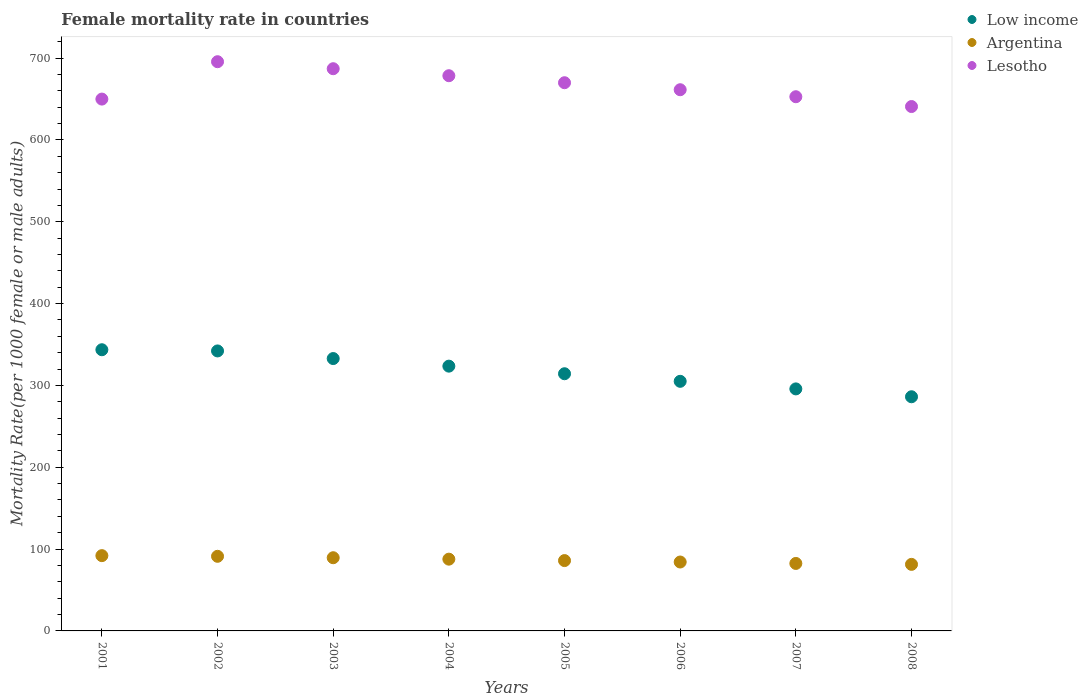How many different coloured dotlines are there?
Provide a short and direct response. 3. Is the number of dotlines equal to the number of legend labels?
Ensure brevity in your answer.  Yes. What is the female mortality rate in Low income in 2005?
Give a very brief answer. 314.28. Across all years, what is the maximum female mortality rate in Argentina?
Make the answer very short. 91.99. Across all years, what is the minimum female mortality rate in Argentina?
Ensure brevity in your answer.  81.32. In which year was the female mortality rate in Low income maximum?
Your answer should be compact. 2001. What is the total female mortality rate in Argentina in the graph?
Give a very brief answer. 694.26. What is the difference between the female mortality rate in Low income in 2006 and that in 2007?
Your response must be concise. 9.27. What is the difference between the female mortality rate in Argentina in 2002 and the female mortality rate in Low income in 2007?
Offer a very short reply. -204.57. What is the average female mortality rate in Low income per year?
Your answer should be compact. 317.92. In the year 2006, what is the difference between the female mortality rate in Low income and female mortality rate in Argentina?
Keep it short and to the point. 220.81. What is the ratio of the female mortality rate in Argentina in 2003 to that in 2006?
Provide a succinct answer. 1.06. Is the female mortality rate in Argentina in 2004 less than that in 2008?
Provide a short and direct response. No. What is the difference between the highest and the second highest female mortality rate in Argentina?
Make the answer very short. 0.81. What is the difference between the highest and the lowest female mortality rate in Lesotho?
Give a very brief answer. 54.78. In how many years, is the female mortality rate in Lesotho greater than the average female mortality rate in Lesotho taken over all years?
Provide a short and direct response. 4. Is the female mortality rate in Argentina strictly greater than the female mortality rate in Low income over the years?
Make the answer very short. No. How many years are there in the graph?
Your answer should be very brief. 8. What is the difference between two consecutive major ticks on the Y-axis?
Keep it short and to the point. 100. Are the values on the major ticks of Y-axis written in scientific E-notation?
Ensure brevity in your answer.  No. Does the graph contain grids?
Ensure brevity in your answer.  No. Where does the legend appear in the graph?
Provide a succinct answer. Top right. How many legend labels are there?
Offer a very short reply. 3. How are the legend labels stacked?
Ensure brevity in your answer.  Vertical. What is the title of the graph?
Provide a succinct answer. Female mortality rate in countries. Does "North America" appear as one of the legend labels in the graph?
Provide a succinct answer. No. What is the label or title of the X-axis?
Offer a very short reply. Years. What is the label or title of the Y-axis?
Make the answer very short. Mortality Rate(per 1000 female or male adults). What is the Mortality Rate(per 1000 female or male adults) in Low income in 2001?
Ensure brevity in your answer.  343.61. What is the Mortality Rate(per 1000 female or male adults) in Argentina in 2001?
Give a very brief answer. 91.99. What is the Mortality Rate(per 1000 female or male adults) of Lesotho in 2001?
Offer a very short reply. 649.91. What is the Mortality Rate(per 1000 female or male adults) of Low income in 2002?
Ensure brevity in your answer.  342.15. What is the Mortality Rate(per 1000 female or male adults) of Argentina in 2002?
Provide a succinct answer. 91.19. What is the Mortality Rate(per 1000 female or male adults) of Lesotho in 2002?
Offer a very short reply. 695.58. What is the Mortality Rate(per 1000 female or male adults) in Low income in 2003?
Offer a terse response. 332.83. What is the Mortality Rate(per 1000 female or male adults) in Argentina in 2003?
Provide a succinct answer. 89.44. What is the Mortality Rate(per 1000 female or male adults) of Lesotho in 2003?
Ensure brevity in your answer.  687.02. What is the Mortality Rate(per 1000 female or male adults) in Low income in 2004?
Your answer should be compact. 323.55. What is the Mortality Rate(per 1000 female or male adults) in Argentina in 2004?
Ensure brevity in your answer.  87.7. What is the Mortality Rate(per 1000 female or male adults) of Lesotho in 2004?
Your answer should be very brief. 678.46. What is the Mortality Rate(per 1000 female or male adults) of Low income in 2005?
Your answer should be very brief. 314.28. What is the Mortality Rate(per 1000 female or male adults) in Argentina in 2005?
Give a very brief answer. 85.95. What is the Mortality Rate(per 1000 female or male adults) in Lesotho in 2005?
Ensure brevity in your answer.  669.9. What is the Mortality Rate(per 1000 female or male adults) in Low income in 2006?
Your response must be concise. 305.02. What is the Mortality Rate(per 1000 female or male adults) of Argentina in 2006?
Ensure brevity in your answer.  84.21. What is the Mortality Rate(per 1000 female or male adults) in Lesotho in 2006?
Keep it short and to the point. 661.34. What is the Mortality Rate(per 1000 female or male adults) of Low income in 2007?
Provide a short and direct response. 295.75. What is the Mortality Rate(per 1000 female or male adults) in Argentina in 2007?
Your answer should be compact. 82.46. What is the Mortality Rate(per 1000 female or male adults) in Lesotho in 2007?
Offer a terse response. 652.78. What is the Mortality Rate(per 1000 female or male adults) of Low income in 2008?
Ensure brevity in your answer.  286.15. What is the Mortality Rate(per 1000 female or male adults) in Argentina in 2008?
Your answer should be compact. 81.32. What is the Mortality Rate(per 1000 female or male adults) in Lesotho in 2008?
Keep it short and to the point. 640.81. Across all years, what is the maximum Mortality Rate(per 1000 female or male adults) of Low income?
Ensure brevity in your answer.  343.61. Across all years, what is the maximum Mortality Rate(per 1000 female or male adults) in Argentina?
Provide a short and direct response. 91.99. Across all years, what is the maximum Mortality Rate(per 1000 female or male adults) of Lesotho?
Provide a succinct answer. 695.58. Across all years, what is the minimum Mortality Rate(per 1000 female or male adults) in Low income?
Make the answer very short. 286.15. Across all years, what is the minimum Mortality Rate(per 1000 female or male adults) in Argentina?
Ensure brevity in your answer.  81.32. Across all years, what is the minimum Mortality Rate(per 1000 female or male adults) in Lesotho?
Give a very brief answer. 640.81. What is the total Mortality Rate(per 1000 female or male adults) in Low income in the graph?
Provide a short and direct response. 2543.33. What is the total Mortality Rate(per 1000 female or male adults) of Argentina in the graph?
Your response must be concise. 694.26. What is the total Mortality Rate(per 1000 female or male adults) in Lesotho in the graph?
Keep it short and to the point. 5335.82. What is the difference between the Mortality Rate(per 1000 female or male adults) of Low income in 2001 and that in 2002?
Ensure brevity in your answer.  1.46. What is the difference between the Mortality Rate(per 1000 female or male adults) in Argentina in 2001 and that in 2002?
Your answer should be compact. 0.81. What is the difference between the Mortality Rate(per 1000 female or male adults) in Lesotho in 2001 and that in 2002?
Ensure brevity in your answer.  -45.67. What is the difference between the Mortality Rate(per 1000 female or male adults) of Low income in 2001 and that in 2003?
Make the answer very short. 10.77. What is the difference between the Mortality Rate(per 1000 female or male adults) in Argentina in 2001 and that in 2003?
Your response must be concise. 2.55. What is the difference between the Mortality Rate(per 1000 female or male adults) of Lesotho in 2001 and that in 2003?
Provide a succinct answer. -37.11. What is the difference between the Mortality Rate(per 1000 female or male adults) in Low income in 2001 and that in 2004?
Ensure brevity in your answer.  20.06. What is the difference between the Mortality Rate(per 1000 female or male adults) of Argentina in 2001 and that in 2004?
Make the answer very short. 4.3. What is the difference between the Mortality Rate(per 1000 female or male adults) of Lesotho in 2001 and that in 2004?
Your response must be concise. -28.55. What is the difference between the Mortality Rate(per 1000 female or male adults) of Low income in 2001 and that in 2005?
Offer a very short reply. 29.33. What is the difference between the Mortality Rate(per 1000 female or male adults) in Argentina in 2001 and that in 2005?
Give a very brief answer. 6.04. What is the difference between the Mortality Rate(per 1000 female or male adults) in Lesotho in 2001 and that in 2005?
Offer a very short reply. -19.99. What is the difference between the Mortality Rate(per 1000 female or male adults) of Low income in 2001 and that in 2006?
Keep it short and to the point. 38.59. What is the difference between the Mortality Rate(per 1000 female or male adults) of Argentina in 2001 and that in 2006?
Your answer should be compact. 7.79. What is the difference between the Mortality Rate(per 1000 female or male adults) in Lesotho in 2001 and that in 2006?
Your answer should be very brief. -11.43. What is the difference between the Mortality Rate(per 1000 female or male adults) in Low income in 2001 and that in 2007?
Provide a succinct answer. 47.85. What is the difference between the Mortality Rate(per 1000 female or male adults) in Argentina in 2001 and that in 2007?
Make the answer very short. 9.53. What is the difference between the Mortality Rate(per 1000 female or male adults) of Lesotho in 2001 and that in 2007?
Make the answer very short. -2.88. What is the difference between the Mortality Rate(per 1000 female or male adults) of Low income in 2001 and that in 2008?
Provide a short and direct response. 57.46. What is the difference between the Mortality Rate(per 1000 female or male adults) in Argentina in 2001 and that in 2008?
Give a very brief answer. 10.67. What is the difference between the Mortality Rate(per 1000 female or male adults) of Lesotho in 2001 and that in 2008?
Offer a terse response. 9.1. What is the difference between the Mortality Rate(per 1000 female or male adults) in Low income in 2002 and that in 2003?
Ensure brevity in your answer.  9.31. What is the difference between the Mortality Rate(per 1000 female or male adults) in Argentina in 2002 and that in 2003?
Give a very brief answer. 1.75. What is the difference between the Mortality Rate(per 1000 female or male adults) of Lesotho in 2002 and that in 2003?
Offer a very short reply. 8.56. What is the difference between the Mortality Rate(per 1000 female or male adults) in Low income in 2002 and that in 2004?
Provide a succinct answer. 18.6. What is the difference between the Mortality Rate(per 1000 female or male adults) in Argentina in 2002 and that in 2004?
Give a very brief answer. 3.49. What is the difference between the Mortality Rate(per 1000 female or male adults) of Lesotho in 2002 and that in 2004?
Offer a very short reply. 17.12. What is the difference between the Mortality Rate(per 1000 female or male adults) in Low income in 2002 and that in 2005?
Offer a terse response. 27.87. What is the difference between the Mortality Rate(per 1000 female or male adults) in Argentina in 2002 and that in 2005?
Your answer should be compact. 5.24. What is the difference between the Mortality Rate(per 1000 female or male adults) of Lesotho in 2002 and that in 2005?
Provide a succinct answer. 25.68. What is the difference between the Mortality Rate(per 1000 female or male adults) of Low income in 2002 and that in 2006?
Your answer should be very brief. 37.13. What is the difference between the Mortality Rate(per 1000 female or male adults) of Argentina in 2002 and that in 2006?
Provide a succinct answer. 6.98. What is the difference between the Mortality Rate(per 1000 female or male adults) in Lesotho in 2002 and that in 2006?
Keep it short and to the point. 34.24. What is the difference between the Mortality Rate(per 1000 female or male adults) of Low income in 2002 and that in 2007?
Offer a terse response. 46.39. What is the difference between the Mortality Rate(per 1000 female or male adults) of Argentina in 2002 and that in 2007?
Provide a succinct answer. 8.73. What is the difference between the Mortality Rate(per 1000 female or male adults) in Lesotho in 2002 and that in 2007?
Provide a short and direct response. 42.8. What is the difference between the Mortality Rate(per 1000 female or male adults) in Low income in 2002 and that in 2008?
Give a very brief answer. 56. What is the difference between the Mortality Rate(per 1000 female or male adults) in Argentina in 2002 and that in 2008?
Your answer should be very brief. 9.87. What is the difference between the Mortality Rate(per 1000 female or male adults) of Lesotho in 2002 and that in 2008?
Give a very brief answer. 54.78. What is the difference between the Mortality Rate(per 1000 female or male adults) of Low income in 2003 and that in 2004?
Offer a very short reply. 9.29. What is the difference between the Mortality Rate(per 1000 female or male adults) in Argentina in 2003 and that in 2004?
Provide a succinct answer. 1.75. What is the difference between the Mortality Rate(per 1000 female or male adults) in Lesotho in 2003 and that in 2004?
Provide a succinct answer. 8.56. What is the difference between the Mortality Rate(per 1000 female or male adults) in Low income in 2003 and that in 2005?
Ensure brevity in your answer.  18.56. What is the difference between the Mortality Rate(per 1000 female or male adults) of Argentina in 2003 and that in 2005?
Make the answer very short. 3.49. What is the difference between the Mortality Rate(per 1000 female or male adults) of Lesotho in 2003 and that in 2005?
Ensure brevity in your answer.  17.12. What is the difference between the Mortality Rate(per 1000 female or male adults) in Low income in 2003 and that in 2006?
Your answer should be very brief. 27.82. What is the difference between the Mortality Rate(per 1000 female or male adults) in Argentina in 2003 and that in 2006?
Ensure brevity in your answer.  5.24. What is the difference between the Mortality Rate(per 1000 female or male adults) of Lesotho in 2003 and that in 2006?
Your answer should be very brief. 25.68. What is the difference between the Mortality Rate(per 1000 female or male adults) of Low income in 2003 and that in 2007?
Your response must be concise. 37.08. What is the difference between the Mortality Rate(per 1000 female or male adults) in Argentina in 2003 and that in 2007?
Give a very brief answer. 6.98. What is the difference between the Mortality Rate(per 1000 female or male adults) of Lesotho in 2003 and that in 2007?
Keep it short and to the point. 34.24. What is the difference between the Mortality Rate(per 1000 female or male adults) of Low income in 2003 and that in 2008?
Keep it short and to the point. 46.69. What is the difference between the Mortality Rate(per 1000 female or male adults) in Argentina in 2003 and that in 2008?
Your answer should be very brief. 8.12. What is the difference between the Mortality Rate(per 1000 female or male adults) of Lesotho in 2003 and that in 2008?
Give a very brief answer. 46.22. What is the difference between the Mortality Rate(per 1000 female or male adults) in Low income in 2004 and that in 2005?
Ensure brevity in your answer.  9.27. What is the difference between the Mortality Rate(per 1000 female or male adults) of Argentina in 2004 and that in 2005?
Ensure brevity in your answer.  1.75. What is the difference between the Mortality Rate(per 1000 female or male adults) in Lesotho in 2004 and that in 2005?
Keep it short and to the point. 8.56. What is the difference between the Mortality Rate(per 1000 female or male adults) in Low income in 2004 and that in 2006?
Your answer should be very brief. 18.53. What is the difference between the Mortality Rate(per 1000 female or male adults) of Argentina in 2004 and that in 2006?
Give a very brief answer. 3.49. What is the difference between the Mortality Rate(per 1000 female or male adults) in Lesotho in 2004 and that in 2006?
Keep it short and to the point. 17.12. What is the difference between the Mortality Rate(per 1000 female or male adults) of Low income in 2004 and that in 2007?
Your answer should be very brief. 27.8. What is the difference between the Mortality Rate(per 1000 female or male adults) in Argentina in 2004 and that in 2007?
Ensure brevity in your answer.  5.24. What is the difference between the Mortality Rate(per 1000 female or male adults) in Lesotho in 2004 and that in 2007?
Provide a short and direct response. 25.68. What is the difference between the Mortality Rate(per 1000 female or male adults) of Low income in 2004 and that in 2008?
Provide a succinct answer. 37.4. What is the difference between the Mortality Rate(per 1000 female or male adults) in Argentina in 2004 and that in 2008?
Your answer should be compact. 6.38. What is the difference between the Mortality Rate(per 1000 female or male adults) of Lesotho in 2004 and that in 2008?
Keep it short and to the point. 37.66. What is the difference between the Mortality Rate(per 1000 female or male adults) of Low income in 2005 and that in 2006?
Ensure brevity in your answer.  9.26. What is the difference between the Mortality Rate(per 1000 female or male adults) in Argentina in 2005 and that in 2006?
Keep it short and to the point. 1.75. What is the difference between the Mortality Rate(per 1000 female or male adults) of Lesotho in 2005 and that in 2006?
Your answer should be compact. 8.56. What is the difference between the Mortality Rate(per 1000 female or male adults) in Low income in 2005 and that in 2007?
Offer a very short reply. 18.53. What is the difference between the Mortality Rate(per 1000 female or male adults) of Argentina in 2005 and that in 2007?
Offer a terse response. 3.49. What is the difference between the Mortality Rate(per 1000 female or male adults) in Lesotho in 2005 and that in 2007?
Offer a very short reply. 17.12. What is the difference between the Mortality Rate(per 1000 female or male adults) in Low income in 2005 and that in 2008?
Offer a very short reply. 28.13. What is the difference between the Mortality Rate(per 1000 female or male adults) in Argentina in 2005 and that in 2008?
Keep it short and to the point. 4.63. What is the difference between the Mortality Rate(per 1000 female or male adults) in Lesotho in 2005 and that in 2008?
Offer a terse response. 29.1. What is the difference between the Mortality Rate(per 1000 female or male adults) in Low income in 2006 and that in 2007?
Offer a terse response. 9.27. What is the difference between the Mortality Rate(per 1000 female or male adults) in Argentina in 2006 and that in 2007?
Your response must be concise. 1.75. What is the difference between the Mortality Rate(per 1000 female or male adults) of Lesotho in 2006 and that in 2007?
Make the answer very short. 8.56. What is the difference between the Mortality Rate(per 1000 female or male adults) in Low income in 2006 and that in 2008?
Make the answer very short. 18.87. What is the difference between the Mortality Rate(per 1000 female or male adults) in Argentina in 2006 and that in 2008?
Offer a very short reply. 2.88. What is the difference between the Mortality Rate(per 1000 female or male adults) in Lesotho in 2006 and that in 2008?
Offer a terse response. 20.54. What is the difference between the Mortality Rate(per 1000 female or male adults) in Low income in 2007 and that in 2008?
Your response must be concise. 9.61. What is the difference between the Mortality Rate(per 1000 female or male adults) of Argentina in 2007 and that in 2008?
Offer a terse response. 1.14. What is the difference between the Mortality Rate(per 1000 female or male adults) of Lesotho in 2007 and that in 2008?
Your answer should be very brief. 11.98. What is the difference between the Mortality Rate(per 1000 female or male adults) of Low income in 2001 and the Mortality Rate(per 1000 female or male adults) of Argentina in 2002?
Offer a very short reply. 252.42. What is the difference between the Mortality Rate(per 1000 female or male adults) of Low income in 2001 and the Mortality Rate(per 1000 female or male adults) of Lesotho in 2002?
Offer a terse response. -351.98. What is the difference between the Mortality Rate(per 1000 female or male adults) of Argentina in 2001 and the Mortality Rate(per 1000 female or male adults) of Lesotho in 2002?
Your answer should be very brief. -603.59. What is the difference between the Mortality Rate(per 1000 female or male adults) in Low income in 2001 and the Mortality Rate(per 1000 female or male adults) in Argentina in 2003?
Ensure brevity in your answer.  254.16. What is the difference between the Mortality Rate(per 1000 female or male adults) of Low income in 2001 and the Mortality Rate(per 1000 female or male adults) of Lesotho in 2003?
Give a very brief answer. -343.42. What is the difference between the Mortality Rate(per 1000 female or male adults) in Argentina in 2001 and the Mortality Rate(per 1000 female or male adults) in Lesotho in 2003?
Your answer should be very brief. -595.03. What is the difference between the Mortality Rate(per 1000 female or male adults) of Low income in 2001 and the Mortality Rate(per 1000 female or male adults) of Argentina in 2004?
Your answer should be very brief. 255.91. What is the difference between the Mortality Rate(per 1000 female or male adults) in Low income in 2001 and the Mortality Rate(per 1000 female or male adults) in Lesotho in 2004?
Your response must be concise. -334.86. What is the difference between the Mortality Rate(per 1000 female or male adults) in Argentina in 2001 and the Mortality Rate(per 1000 female or male adults) in Lesotho in 2004?
Your answer should be compact. -586.47. What is the difference between the Mortality Rate(per 1000 female or male adults) of Low income in 2001 and the Mortality Rate(per 1000 female or male adults) of Argentina in 2005?
Ensure brevity in your answer.  257.65. What is the difference between the Mortality Rate(per 1000 female or male adults) of Low income in 2001 and the Mortality Rate(per 1000 female or male adults) of Lesotho in 2005?
Offer a very short reply. -326.3. What is the difference between the Mortality Rate(per 1000 female or male adults) in Argentina in 2001 and the Mortality Rate(per 1000 female or male adults) in Lesotho in 2005?
Offer a very short reply. -577.91. What is the difference between the Mortality Rate(per 1000 female or male adults) in Low income in 2001 and the Mortality Rate(per 1000 female or male adults) in Argentina in 2006?
Make the answer very short. 259.4. What is the difference between the Mortality Rate(per 1000 female or male adults) of Low income in 2001 and the Mortality Rate(per 1000 female or male adults) of Lesotho in 2006?
Offer a terse response. -317.74. What is the difference between the Mortality Rate(per 1000 female or male adults) in Argentina in 2001 and the Mortality Rate(per 1000 female or male adults) in Lesotho in 2006?
Offer a terse response. -569.35. What is the difference between the Mortality Rate(per 1000 female or male adults) of Low income in 2001 and the Mortality Rate(per 1000 female or male adults) of Argentina in 2007?
Make the answer very short. 261.14. What is the difference between the Mortality Rate(per 1000 female or male adults) in Low income in 2001 and the Mortality Rate(per 1000 female or male adults) in Lesotho in 2007?
Provide a short and direct response. -309.18. What is the difference between the Mortality Rate(per 1000 female or male adults) of Argentina in 2001 and the Mortality Rate(per 1000 female or male adults) of Lesotho in 2007?
Keep it short and to the point. -560.79. What is the difference between the Mortality Rate(per 1000 female or male adults) of Low income in 2001 and the Mortality Rate(per 1000 female or male adults) of Argentina in 2008?
Provide a succinct answer. 262.28. What is the difference between the Mortality Rate(per 1000 female or male adults) in Low income in 2001 and the Mortality Rate(per 1000 female or male adults) in Lesotho in 2008?
Your response must be concise. -297.2. What is the difference between the Mortality Rate(per 1000 female or male adults) in Argentina in 2001 and the Mortality Rate(per 1000 female or male adults) in Lesotho in 2008?
Offer a terse response. -548.81. What is the difference between the Mortality Rate(per 1000 female or male adults) in Low income in 2002 and the Mortality Rate(per 1000 female or male adults) in Argentina in 2003?
Your answer should be compact. 252.7. What is the difference between the Mortality Rate(per 1000 female or male adults) of Low income in 2002 and the Mortality Rate(per 1000 female or male adults) of Lesotho in 2003?
Ensure brevity in your answer.  -344.88. What is the difference between the Mortality Rate(per 1000 female or male adults) of Argentina in 2002 and the Mortality Rate(per 1000 female or male adults) of Lesotho in 2003?
Keep it short and to the point. -595.84. What is the difference between the Mortality Rate(per 1000 female or male adults) of Low income in 2002 and the Mortality Rate(per 1000 female or male adults) of Argentina in 2004?
Ensure brevity in your answer.  254.45. What is the difference between the Mortality Rate(per 1000 female or male adults) in Low income in 2002 and the Mortality Rate(per 1000 female or male adults) in Lesotho in 2004?
Your response must be concise. -336.32. What is the difference between the Mortality Rate(per 1000 female or male adults) of Argentina in 2002 and the Mortality Rate(per 1000 female or male adults) of Lesotho in 2004?
Make the answer very short. -587.28. What is the difference between the Mortality Rate(per 1000 female or male adults) in Low income in 2002 and the Mortality Rate(per 1000 female or male adults) in Argentina in 2005?
Ensure brevity in your answer.  256.19. What is the difference between the Mortality Rate(per 1000 female or male adults) of Low income in 2002 and the Mortality Rate(per 1000 female or male adults) of Lesotho in 2005?
Provide a short and direct response. -327.76. What is the difference between the Mortality Rate(per 1000 female or male adults) of Argentina in 2002 and the Mortality Rate(per 1000 female or male adults) of Lesotho in 2005?
Make the answer very short. -578.72. What is the difference between the Mortality Rate(per 1000 female or male adults) of Low income in 2002 and the Mortality Rate(per 1000 female or male adults) of Argentina in 2006?
Provide a succinct answer. 257.94. What is the difference between the Mortality Rate(per 1000 female or male adults) in Low income in 2002 and the Mortality Rate(per 1000 female or male adults) in Lesotho in 2006?
Your response must be concise. -319.2. What is the difference between the Mortality Rate(per 1000 female or male adults) of Argentina in 2002 and the Mortality Rate(per 1000 female or male adults) of Lesotho in 2006?
Give a very brief answer. -570.16. What is the difference between the Mortality Rate(per 1000 female or male adults) in Low income in 2002 and the Mortality Rate(per 1000 female or male adults) in Argentina in 2007?
Provide a short and direct response. 259.69. What is the difference between the Mortality Rate(per 1000 female or male adults) in Low income in 2002 and the Mortality Rate(per 1000 female or male adults) in Lesotho in 2007?
Keep it short and to the point. -310.64. What is the difference between the Mortality Rate(per 1000 female or male adults) of Argentina in 2002 and the Mortality Rate(per 1000 female or male adults) of Lesotho in 2007?
Offer a terse response. -561.6. What is the difference between the Mortality Rate(per 1000 female or male adults) of Low income in 2002 and the Mortality Rate(per 1000 female or male adults) of Argentina in 2008?
Your answer should be very brief. 260.83. What is the difference between the Mortality Rate(per 1000 female or male adults) in Low income in 2002 and the Mortality Rate(per 1000 female or male adults) in Lesotho in 2008?
Make the answer very short. -298.66. What is the difference between the Mortality Rate(per 1000 female or male adults) in Argentina in 2002 and the Mortality Rate(per 1000 female or male adults) in Lesotho in 2008?
Your response must be concise. -549.62. What is the difference between the Mortality Rate(per 1000 female or male adults) of Low income in 2003 and the Mortality Rate(per 1000 female or male adults) of Argentina in 2004?
Make the answer very short. 245.14. What is the difference between the Mortality Rate(per 1000 female or male adults) of Low income in 2003 and the Mortality Rate(per 1000 female or male adults) of Lesotho in 2004?
Your answer should be compact. -345.63. What is the difference between the Mortality Rate(per 1000 female or male adults) of Argentina in 2003 and the Mortality Rate(per 1000 female or male adults) of Lesotho in 2004?
Give a very brief answer. -589.02. What is the difference between the Mortality Rate(per 1000 female or male adults) in Low income in 2003 and the Mortality Rate(per 1000 female or male adults) in Argentina in 2005?
Offer a terse response. 246.88. What is the difference between the Mortality Rate(per 1000 female or male adults) of Low income in 2003 and the Mortality Rate(per 1000 female or male adults) of Lesotho in 2005?
Make the answer very short. -337.07. What is the difference between the Mortality Rate(per 1000 female or male adults) of Argentina in 2003 and the Mortality Rate(per 1000 female or male adults) of Lesotho in 2005?
Your answer should be very brief. -580.46. What is the difference between the Mortality Rate(per 1000 female or male adults) of Low income in 2003 and the Mortality Rate(per 1000 female or male adults) of Argentina in 2006?
Keep it short and to the point. 248.63. What is the difference between the Mortality Rate(per 1000 female or male adults) in Low income in 2003 and the Mortality Rate(per 1000 female or male adults) in Lesotho in 2006?
Your response must be concise. -328.51. What is the difference between the Mortality Rate(per 1000 female or male adults) of Argentina in 2003 and the Mortality Rate(per 1000 female or male adults) of Lesotho in 2006?
Provide a short and direct response. -571.9. What is the difference between the Mortality Rate(per 1000 female or male adults) of Low income in 2003 and the Mortality Rate(per 1000 female or male adults) of Argentina in 2007?
Ensure brevity in your answer.  250.37. What is the difference between the Mortality Rate(per 1000 female or male adults) in Low income in 2003 and the Mortality Rate(per 1000 female or male adults) in Lesotho in 2007?
Provide a short and direct response. -319.95. What is the difference between the Mortality Rate(per 1000 female or male adults) in Argentina in 2003 and the Mortality Rate(per 1000 female or male adults) in Lesotho in 2007?
Provide a succinct answer. -563.34. What is the difference between the Mortality Rate(per 1000 female or male adults) of Low income in 2003 and the Mortality Rate(per 1000 female or male adults) of Argentina in 2008?
Offer a terse response. 251.51. What is the difference between the Mortality Rate(per 1000 female or male adults) of Low income in 2003 and the Mortality Rate(per 1000 female or male adults) of Lesotho in 2008?
Make the answer very short. -307.97. What is the difference between the Mortality Rate(per 1000 female or male adults) of Argentina in 2003 and the Mortality Rate(per 1000 female or male adults) of Lesotho in 2008?
Your response must be concise. -551.36. What is the difference between the Mortality Rate(per 1000 female or male adults) in Low income in 2004 and the Mortality Rate(per 1000 female or male adults) in Argentina in 2005?
Ensure brevity in your answer.  237.6. What is the difference between the Mortality Rate(per 1000 female or male adults) of Low income in 2004 and the Mortality Rate(per 1000 female or male adults) of Lesotho in 2005?
Offer a very short reply. -346.35. What is the difference between the Mortality Rate(per 1000 female or male adults) in Argentina in 2004 and the Mortality Rate(per 1000 female or male adults) in Lesotho in 2005?
Offer a terse response. -582.21. What is the difference between the Mortality Rate(per 1000 female or male adults) in Low income in 2004 and the Mortality Rate(per 1000 female or male adults) in Argentina in 2006?
Make the answer very short. 239.34. What is the difference between the Mortality Rate(per 1000 female or male adults) in Low income in 2004 and the Mortality Rate(per 1000 female or male adults) in Lesotho in 2006?
Offer a very short reply. -337.79. What is the difference between the Mortality Rate(per 1000 female or male adults) of Argentina in 2004 and the Mortality Rate(per 1000 female or male adults) of Lesotho in 2006?
Your answer should be very brief. -573.65. What is the difference between the Mortality Rate(per 1000 female or male adults) of Low income in 2004 and the Mortality Rate(per 1000 female or male adults) of Argentina in 2007?
Offer a terse response. 241.09. What is the difference between the Mortality Rate(per 1000 female or male adults) in Low income in 2004 and the Mortality Rate(per 1000 female or male adults) in Lesotho in 2007?
Your answer should be compact. -329.24. What is the difference between the Mortality Rate(per 1000 female or male adults) in Argentina in 2004 and the Mortality Rate(per 1000 female or male adults) in Lesotho in 2007?
Provide a short and direct response. -565.09. What is the difference between the Mortality Rate(per 1000 female or male adults) in Low income in 2004 and the Mortality Rate(per 1000 female or male adults) in Argentina in 2008?
Give a very brief answer. 242.23. What is the difference between the Mortality Rate(per 1000 female or male adults) in Low income in 2004 and the Mortality Rate(per 1000 female or male adults) in Lesotho in 2008?
Keep it short and to the point. -317.26. What is the difference between the Mortality Rate(per 1000 female or male adults) of Argentina in 2004 and the Mortality Rate(per 1000 female or male adults) of Lesotho in 2008?
Make the answer very short. -553.11. What is the difference between the Mortality Rate(per 1000 female or male adults) of Low income in 2005 and the Mortality Rate(per 1000 female or male adults) of Argentina in 2006?
Ensure brevity in your answer.  230.07. What is the difference between the Mortality Rate(per 1000 female or male adults) in Low income in 2005 and the Mortality Rate(per 1000 female or male adults) in Lesotho in 2006?
Your response must be concise. -347.07. What is the difference between the Mortality Rate(per 1000 female or male adults) of Argentina in 2005 and the Mortality Rate(per 1000 female or male adults) of Lesotho in 2006?
Your answer should be compact. -575.39. What is the difference between the Mortality Rate(per 1000 female or male adults) of Low income in 2005 and the Mortality Rate(per 1000 female or male adults) of Argentina in 2007?
Your response must be concise. 231.82. What is the difference between the Mortality Rate(per 1000 female or male adults) in Low income in 2005 and the Mortality Rate(per 1000 female or male adults) in Lesotho in 2007?
Your response must be concise. -338.51. What is the difference between the Mortality Rate(per 1000 female or male adults) in Argentina in 2005 and the Mortality Rate(per 1000 female or male adults) in Lesotho in 2007?
Your answer should be compact. -566.83. What is the difference between the Mortality Rate(per 1000 female or male adults) of Low income in 2005 and the Mortality Rate(per 1000 female or male adults) of Argentina in 2008?
Make the answer very short. 232.96. What is the difference between the Mortality Rate(per 1000 female or male adults) in Low income in 2005 and the Mortality Rate(per 1000 female or male adults) in Lesotho in 2008?
Ensure brevity in your answer.  -326.53. What is the difference between the Mortality Rate(per 1000 female or male adults) of Argentina in 2005 and the Mortality Rate(per 1000 female or male adults) of Lesotho in 2008?
Provide a succinct answer. -554.85. What is the difference between the Mortality Rate(per 1000 female or male adults) of Low income in 2006 and the Mortality Rate(per 1000 female or male adults) of Argentina in 2007?
Offer a terse response. 222.56. What is the difference between the Mortality Rate(per 1000 female or male adults) of Low income in 2006 and the Mortality Rate(per 1000 female or male adults) of Lesotho in 2007?
Provide a short and direct response. -347.77. What is the difference between the Mortality Rate(per 1000 female or male adults) of Argentina in 2006 and the Mortality Rate(per 1000 female or male adults) of Lesotho in 2007?
Offer a terse response. -568.58. What is the difference between the Mortality Rate(per 1000 female or male adults) in Low income in 2006 and the Mortality Rate(per 1000 female or male adults) in Argentina in 2008?
Make the answer very short. 223.7. What is the difference between the Mortality Rate(per 1000 female or male adults) of Low income in 2006 and the Mortality Rate(per 1000 female or male adults) of Lesotho in 2008?
Your response must be concise. -335.79. What is the difference between the Mortality Rate(per 1000 female or male adults) of Argentina in 2006 and the Mortality Rate(per 1000 female or male adults) of Lesotho in 2008?
Offer a terse response. -556.6. What is the difference between the Mortality Rate(per 1000 female or male adults) in Low income in 2007 and the Mortality Rate(per 1000 female or male adults) in Argentina in 2008?
Offer a very short reply. 214.43. What is the difference between the Mortality Rate(per 1000 female or male adults) of Low income in 2007 and the Mortality Rate(per 1000 female or male adults) of Lesotho in 2008?
Your answer should be very brief. -345.05. What is the difference between the Mortality Rate(per 1000 female or male adults) in Argentina in 2007 and the Mortality Rate(per 1000 female or male adults) in Lesotho in 2008?
Provide a succinct answer. -558.35. What is the average Mortality Rate(per 1000 female or male adults) of Low income per year?
Offer a terse response. 317.92. What is the average Mortality Rate(per 1000 female or male adults) of Argentina per year?
Give a very brief answer. 86.78. What is the average Mortality Rate(per 1000 female or male adults) in Lesotho per year?
Your answer should be compact. 666.98. In the year 2001, what is the difference between the Mortality Rate(per 1000 female or male adults) of Low income and Mortality Rate(per 1000 female or male adults) of Argentina?
Provide a short and direct response. 251.61. In the year 2001, what is the difference between the Mortality Rate(per 1000 female or male adults) of Low income and Mortality Rate(per 1000 female or male adults) of Lesotho?
Offer a terse response. -306.3. In the year 2001, what is the difference between the Mortality Rate(per 1000 female or male adults) in Argentina and Mortality Rate(per 1000 female or male adults) in Lesotho?
Provide a succinct answer. -557.92. In the year 2002, what is the difference between the Mortality Rate(per 1000 female or male adults) of Low income and Mortality Rate(per 1000 female or male adults) of Argentina?
Offer a very short reply. 250.96. In the year 2002, what is the difference between the Mortality Rate(per 1000 female or male adults) of Low income and Mortality Rate(per 1000 female or male adults) of Lesotho?
Offer a terse response. -353.44. In the year 2002, what is the difference between the Mortality Rate(per 1000 female or male adults) of Argentina and Mortality Rate(per 1000 female or male adults) of Lesotho?
Give a very brief answer. -604.39. In the year 2003, what is the difference between the Mortality Rate(per 1000 female or male adults) in Low income and Mortality Rate(per 1000 female or male adults) in Argentina?
Your answer should be compact. 243.39. In the year 2003, what is the difference between the Mortality Rate(per 1000 female or male adults) of Low income and Mortality Rate(per 1000 female or male adults) of Lesotho?
Your answer should be very brief. -354.19. In the year 2003, what is the difference between the Mortality Rate(per 1000 female or male adults) of Argentina and Mortality Rate(per 1000 female or male adults) of Lesotho?
Provide a succinct answer. -597.58. In the year 2004, what is the difference between the Mortality Rate(per 1000 female or male adults) in Low income and Mortality Rate(per 1000 female or male adults) in Argentina?
Offer a terse response. 235.85. In the year 2004, what is the difference between the Mortality Rate(per 1000 female or male adults) of Low income and Mortality Rate(per 1000 female or male adults) of Lesotho?
Offer a very short reply. -354.91. In the year 2004, what is the difference between the Mortality Rate(per 1000 female or male adults) of Argentina and Mortality Rate(per 1000 female or male adults) of Lesotho?
Make the answer very short. -590.77. In the year 2005, what is the difference between the Mortality Rate(per 1000 female or male adults) of Low income and Mortality Rate(per 1000 female or male adults) of Argentina?
Keep it short and to the point. 228.33. In the year 2005, what is the difference between the Mortality Rate(per 1000 female or male adults) in Low income and Mortality Rate(per 1000 female or male adults) in Lesotho?
Your answer should be compact. -355.63. In the year 2005, what is the difference between the Mortality Rate(per 1000 female or male adults) in Argentina and Mortality Rate(per 1000 female or male adults) in Lesotho?
Ensure brevity in your answer.  -583.95. In the year 2006, what is the difference between the Mortality Rate(per 1000 female or male adults) of Low income and Mortality Rate(per 1000 female or male adults) of Argentina?
Offer a very short reply. 220.81. In the year 2006, what is the difference between the Mortality Rate(per 1000 female or male adults) in Low income and Mortality Rate(per 1000 female or male adults) in Lesotho?
Provide a succinct answer. -356.33. In the year 2006, what is the difference between the Mortality Rate(per 1000 female or male adults) of Argentina and Mortality Rate(per 1000 female or male adults) of Lesotho?
Offer a very short reply. -577.14. In the year 2007, what is the difference between the Mortality Rate(per 1000 female or male adults) of Low income and Mortality Rate(per 1000 female or male adults) of Argentina?
Your answer should be very brief. 213.29. In the year 2007, what is the difference between the Mortality Rate(per 1000 female or male adults) in Low income and Mortality Rate(per 1000 female or male adults) in Lesotho?
Make the answer very short. -357.03. In the year 2007, what is the difference between the Mortality Rate(per 1000 female or male adults) in Argentina and Mortality Rate(per 1000 female or male adults) in Lesotho?
Provide a short and direct response. -570.32. In the year 2008, what is the difference between the Mortality Rate(per 1000 female or male adults) in Low income and Mortality Rate(per 1000 female or male adults) in Argentina?
Your answer should be compact. 204.82. In the year 2008, what is the difference between the Mortality Rate(per 1000 female or male adults) of Low income and Mortality Rate(per 1000 female or male adults) of Lesotho?
Offer a terse response. -354.66. In the year 2008, what is the difference between the Mortality Rate(per 1000 female or male adults) of Argentina and Mortality Rate(per 1000 female or male adults) of Lesotho?
Make the answer very short. -559.49. What is the ratio of the Mortality Rate(per 1000 female or male adults) in Low income in 2001 to that in 2002?
Offer a very short reply. 1. What is the ratio of the Mortality Rate(per 1000 female or male adults) of Argentina in 2001 to that in 2002?
Your response must be concise. 1.01. What is the ratio of the Mortality Rate(per 1000 female or male adults) of Lesotho in 2001 to that in 2002?
Your answer should be very brief. 0.93. What is the ratio of the Mortality Rate(per 1000 female or male adults) in Low income in 2001 to that in 2003?
Offer a terse response. 1.03. What is the ratio of the Mortality Rate(per 1000 female or male adults) of Argentina in 2001 to that in 2003?
Offer a terse response. 1.03. What is the ratio of the Mortality Rate(per 1000 female or male adults) of Lesotho in 2001 to that in 2003?
Provide a succinct answer. 0.95. What is the ratio of the Mortality Rate(per 1000 female or male adults) of Low income in 2001 to that in 2004?
Your answer should be very brief. 1.06. What is the ratio of the Mortality Rate(per 1000 female or male adults) of Argentina in 2001 to that in 2004?
Offer a terse response. 1.05. What is the ratio of the Mortality Rate(per 1000 female or male adults) in Lesotho in 2001 to that in 2004?
Ensure brevity in your answer.  0.96. What is the ratio of the Mortality Rate(per 1000 female or male adults) of Low income in 2001 to that in 2005?
Provide a succinct answer. 1.09. What is the ratio of the Mortality Rate(per 1000 female or male adults) of Argentina in 2001 to that in 2005?
Offer a very short reply. 1.07. What is the ratio of the Mortality Rate(per 1000 female or male adults) in Lesotho in 2001 to that in 2005?
Provide a short and direct response. 0.97. What is the ratio of the Mortality Rate(per 1000 female or male adults) in Low income in 2001 to that in 2006?
Provide a short and direct response. 1.13. What is the ratio of the Mortality Rate(per 1000 female or male adults) of Argentina in 2001 to that in 2006?
Keep it short and to the point. 1.09. What is the ratio of the Mortality Rate(per 1000 female or male adults) of Lesotho in 2001 to that in 2006?
Offer a very short reply. 0.98. What is the ratio of the Mortality Rate(per 1000 female or male adults) of Low income in 2001 to that in 2007?
Provide a succinct answer. 1.16. What is the ratio of the Mortality Rate(per 1000 female or male adults) in Argentina in 2001 to that in 2007?
Offer a terse response. 1.12. What is the ratio of the Mortality Rate(per 1000 female or male adults) in Low income in 2001 to that in 2008?
Your response must be concise. 1.2. What is the ratio of the Mortality Rate(per 1000 female or male adults) of Argentina in 2001 to that in 2008?
Your answer should be very brief. 1.13. What is the ratio of the Mortality Rate(per 1000 female or male adults) of Lesotho in 2001 to that in 2008?
Keep it short and to the point. 1.01. What is the ratio of the Mortality Rate(per 1000 female or male adults) of Low income in 2002 to that in 2003?
Ensure brevity in your answer.  1.03. What is the ratio of the Mortality Rate(per 1000 female or male adults) in Argentina in 2002 to that in 2003?
Offer a very short reply. 1.02. What is the ratio of the Mortality Rate(per 1000 female or male adults) of Lesotho in 2002 to that in 2003?
Keep it short and to the point. 1.01. What is the ratio of the Mortality Rate(per 1000 female or male adults) of Low income in 2002 to that in 2004?
Provide a short and direct response. 1.06. What is the ratio of the Mortality Rate(per 1000 female or male adults) of Argentina in 2002 to that in 2004?
Ensure brevity in your answer.  1.04. What is the ratio of the Mortality Rate(per 1000 female or male adults) in Lesotho in 2002 to that in 2004?
Keep it short and to the point. 1.03. What is the ratio of the Mortality Rate(per 1000 female or male adults) in Low income in 2002 to that in 2005?
Make the answer very short. 1.09. What is the ratio of the Mortality Rate(per 1000 female or male adults) of Argentina in 2002 to that in 2005?
Provide a short and direct response. 1.06. What is the ratio of the Mortality Rate(per 1000 female or male adults) in Lesotho in 2002 to that in 2005?
Your answer should be very brief. 1.04. What is the ratio of the Mortality Rate(per 1000 female or male adults) in Low income in 2002 to that in 2006?
Keep it short and to the point. 1.12. What is the ratio of the Mortality Rate(per 1000 female or male adults) of Argentina in 2002 to that in 2006?
Ensure brevity in your answer.  1.08. What is the ratio of the Mortality Rate(per 1000 female or male adults) of Lesotho in 2002 to that in 2006?
Your response must be concise. 1.05. What is the ratio of the Mortality Rate(per 1000 female or male adults) in Low income in 2002 to that in 2007?
Provide a succinct answer. 1.16. What is the ratio of the Mortality Rate(per 1000 female or male adults) of Argentina in 2002 to that in 2007?
Ensure brevity in your answer.  1.11. What is the ratio of the Mortality Rate(per 1000 female or male adults) of Lesotho in 2002 to that in 2007?
Ensure brevity in your answer.  1.07. What is the ratio of the Mortality Rate(per 1000 female or male adults) of Low income in 2002 to that in 2008?
Your response must be concise. 1.2. What is the ratio of the Mortality Rate(per 1000 female or male adults) in Argentina in 2002 to that in 2008?
Provide a succinct answer. 1.12. What is the ratio of the Mortality Rate(per 1000 female or male adults) of Lesotho in 2002 to that in 2008?
Keep it short and to the point. 1.09. What is the ratio of the Mortality Rate(per 1000 female or male adults) of Low income in 2003 to that in 2004?
Keep it short and to the point. 1.03. What is the ratio of the Mortality Rate(per 1000 female or male adults) of Argentina in 2003 to that in 2004?
Ensure brevity in your answer.  1.02. What is the ratio of the Mortality Rate(per 1000 female or male adults) of Lesotho in 2003 to that in 2004?
Provide a succinct answer. 1.01. What is the ratio of the Mortality Rate(per 1000 female or male adults) of Low income in 2003 to that in 2005?
Give a very brief answer. 1.06. What is the ratio of the Mortality Rate(per 1000 female or male adults) in Argentina in 2003 to that in 2005?
Offer a terse response. 1.04. What is the ratio of the Mortality Rate(per 1000 female or male adults) in Lesotho in 2003 to that in 2005?
Offer a very short reply. 1.03. What is the ratio of the Mortality Rate(per 1000 female or male adults) in Low income in 2003 to that in 2006?
Your answer should be very brief. 1.09. What is the ratio of the Mortality Rate(per 1000 female or male adults) in Argentina in 2003 to that in 2006?
Your response must be concise. 1.06. What is the ratio of the Mortality Rate(per 1000 female or male adults) in Lesotho in 2003 to that in 2006?
Your answer should be compact. 1.04. What is the ratio of the Mortality Rate(per 1000 female or male adults) of Low income in 2003 to that in 2007?
Your answer should be very brief. 1.13. What is the ratio of the Mortality Rate(per 1000 female or male adults) in Argentina in 2003 to that in 2007?
Provide a succinct answer. 1.08. What is the ratio of the Mortality Rate(per 1000 female or male adults) of Lesotho in 2003 to that in 2007?
Keep it short and to the point. 1.05. What is the ratio of the Mortality Rate(per 1000 female or male adults) in Low income in 2003 to that in 2008?
Offer a terse response. 1.16. What is the ratio of the Mortality Rate(per 1000 female or male adults) in Argentina in 2003 to that in 2008?
Provide a short and direct response. 1.1. What is the ratio of the Mortality Rate(per 1000 female or male adults) of Lesotho in 2003 to that in 2008?
Your response must be concise. 1.07. What is the ratio of the Mortality Rate(per 1000 female or male adults) of Low income in 2004 to that in 2005?
Your answer should be very brief. 1.03. What is the ratio of the Mortality Rate(per 1000 female or male adults) in Argentina in 2004 to that in 2005?
Your response must be concise. 1.02. What is the ratio of the Mortality Rate(per 1000 female or male adults) in Lesotho in 2004 to that in 2005?
Make the answer very short. 1.01. What is the ratio of the Mortality Rate(per 1000 female or male adults) in Low income in 2004 to that in 2006?
Offer a terse response. 1.06. What is the ratio of the Mortality Rate(per 1000 female or male adults) of Argentina in 2004 to that in 2006?
Make the answer very short. 1.04. What is the ratio of the Mortality Rate(per 1000 female or male adults) of Lesotho in 2004 to that in 2006?
Offer a terse response. 1.03. What is the ratio of the Mortality Rate(per 1000 female or male adults) of Low income in 2004 to that in 2007?
Your answer should be very brief. 1.09. What is the ratio of the Mortality Rate(per 1000 female or male adults) in Argentina in 2004 to that in 2007?
Your answer should be compact. 1.06. What is the ratio of the Mortality Rate(per 1000 female or male adults) of Lesotho in 2004 to that in 2007?
Make the answer very short. 1.04. What is the ratio of the Mortality Rate(per 1000 female or male adults) in Low income in 2004 to that in 2008?
Provide a short and direct response. 1.13. What is the ratio of the Mortality Rate(per 1000 female or male adults) in Argentina in 2004 to that in 2008?
Make the answer very short. 1.08. What is the ratio of the Mortality Rate(per 1000 female or male adults) of Lesotho in 2004 to that in 2008?
Your answer should be compact. 1.06. What is the ratio of the Mortality Rate(per 1000 female or male adults) in Low income in 2005 to that in 2006?
Offer a very short reply. 1.03. What is the ratio of the Mortality Rate(per 1000 female or male adults) in Argentina in 2005 to that in 2006?
Provide a succinct answer. 1.02. What is the ratio of the Mortality Rate(per 1000 female or male adults) of Lesotho in 2005 to that in 2006?
Your response must be concise. 1.01. What is the ratio of the Mortality Rate(per 1000 female or male adults) of Low income in 2005 to that in 2007?
Give a very brief answer. 1.06. What is the ratio of the Mortality Rate(per 1000 female or male adults) in Argentina in 2005 to that in 2007?
Keep it short and to the point. 1.04. What is the ratio of the Mortality Rate(per 1000 female or male adults) in Lesotho in 2005 to that in 2007?
Offer a very short reply. 1.03. What is the ratio of the Mortality Rate(per 1000 female or male adults) of Low income in 2005 to that in 2008?
Your response must be concise. 1.1. What is the ratio of the Mortality Rate(per 1000 female or male adults) of Argentina in 2005 to that in 2008?
Offer a very short reply. 1.06. What is the ratio of the Mortality Rate(per 1000 female or male adults) of Lesotho in 2005 to that in 2008?
Your answer should be compact. 1.05. What is the ratio of the Mortality Rate(per 1000 female or male adults) in Low income in 2006 to that in 2007?
Keep it short and to the point. 1.03. What is the ratio of the Mortality Rate(per 1000 female or male adults) in Argentina in 2006 to that in 2007?
Your answer should be compact. 1.02. What is the ratio of the Mortality Rate(per 1000 female or male adults) of Lesotho in 2006 to that in 2007?
Make the answer very short. 1.01. What is the ratio of the Mortality Rate(per 1000 female or male adults) of Low income in 2006 to that in 2008?
Give a very brief answer. 1.07. What is the ratio of the Mortality Rate(per 1000 female or male adults) in Argentina in 2006 to that in 2008?
Give a very brief answer. 1.04. What is the ratio of the Mortality Rate(per 1000 female or male adults) in Lesotho in 2006 to that in 2008?
Provide a succinct answer. 1.03. What is the ratio of the Mortality Rate(per 1000 female or male adults) in Low income in 2007 to that in 2008?
Give a very brief answer. 1.03. What is the ratio of the Mortality Rate(per 1000 female or male adults) in Argentina in 2007 to that in 2008?
Your answer should be very brief. 1.01. What is the ratio of the Mortality Rate(per 1000 female or male adults) in Lesotho in 2007 to that in 2008?
Keep it short and to the point. 1.02. What is the difference between the highest and the second highest Mortality Rate(per 1000 female or male adults) of Low income?
Provide a succinct answer. 1.46. What is the difference between the highest and the second highest Mortality Rate(per 1000 female or male adults) of Argentina?
Offer a very short reply. 0.81. What is the difference between the highest and the second highest Mortality Rate(per 1000 female or male adults) in Lesotho?
Give a very brief answer. 8.56. What is the difference between the highest and the lowest Mortality Rate(per 1000 female or male adults) in Low income?
Your answer should be very brief. 57.46. What is the difference between the highest and the lowest Mortality Rate(per 1000 female or male adults) in Argentina?
Provide a short and direct response. 10.67. What is the difference between the highest and the lowest Mortality Rate(per 1000 female or male adults) in Lesotho?
Provide a short and direct response. 54.78. 